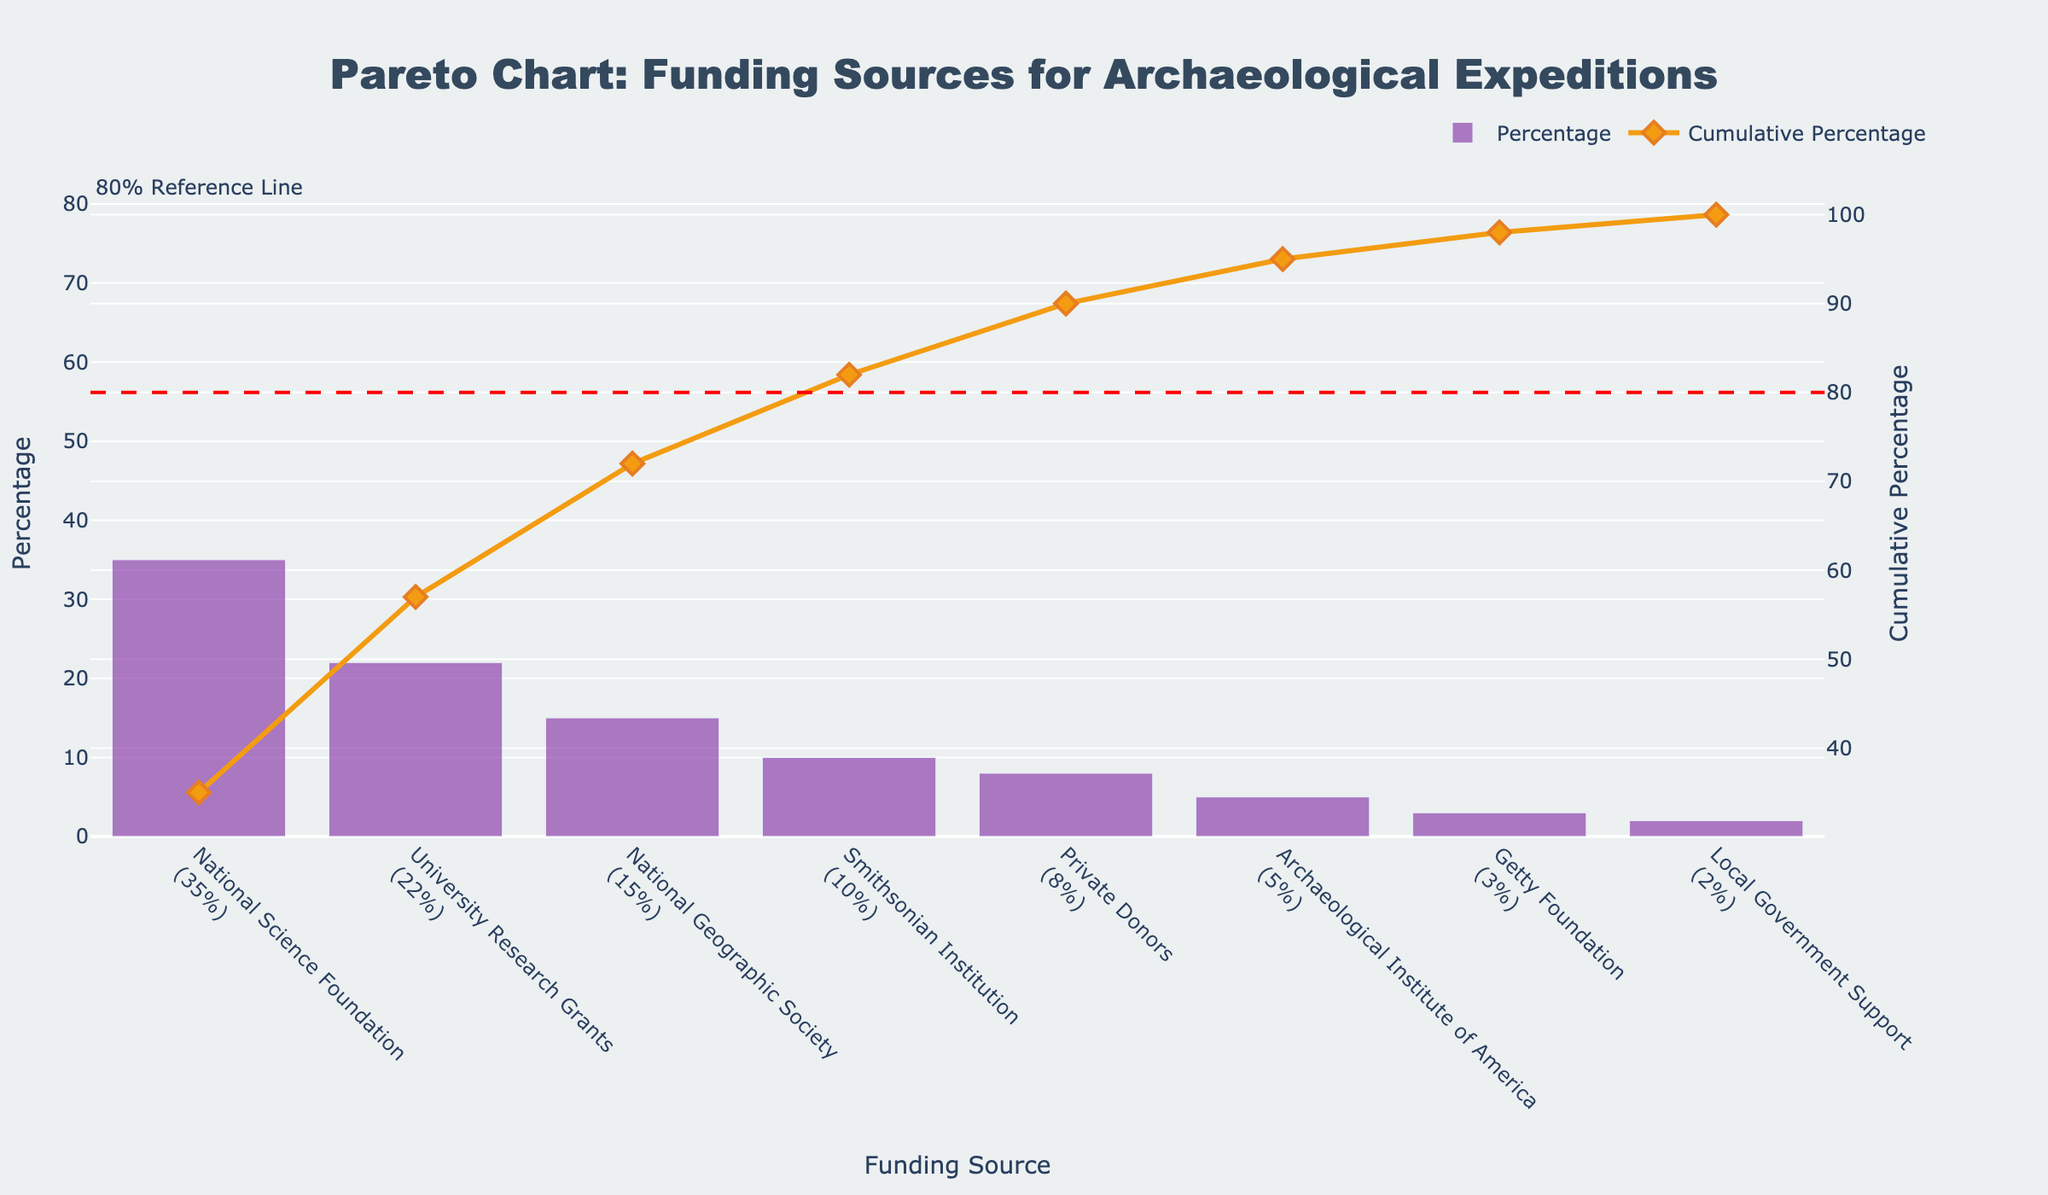What's the main title of this figure? The main title of the figure is displayed at the top, in bold and large font. It describes what the figure is about.
Answer: Pareto Chart: Funding Sources for Archaeological Expeditions Which funding source contributes the highest percentage? The funding sources are displayed along the x-axis, and their corresponding percentages are shown as bars. The tallest bar indicates the highest percentage.
Answer: National Science Foundation How does the cumulative percentage change from the first to the second funding source? The cumulative percentage is shown by the line graph. Observe the values at the first and second x-axis points and subtract.
Answer: It increases by 35% What is the total percentage contribution of the top three funding sources? Sum the percentages of the top three sources (35 + 22 + 15) to find the total.
Answer: 72% Which funding sources combined make up about 80% of the total funding? Look at the cumulative percentage line and find where it reaches around 80%. List down the corresponding funding sources up to that point.
Answer: National Science Foundation, University Research Grants, National Geographic Society, and Smithsonian Institution How many funding sources contribute less than 10% each? Look at the y-axis values and count the number of bars that are below the 10% mark.
Answer: Four (Private Donors, Archaeological Institute of America, Getty Foundation, Local Government Support) Which funding source is represented by the orange line symbol near 80%? The orange line represents the cumulative percentage. Check where this line is around 80% and find the corresponding funding source on the x-axis.
Answer: Smithsonian Institution Compare the contributions of National Geographic Society and Private Donors. Identify the bars for these two sources and compare their heights to determine which is larger and by how much.
Answer: National Geographic Society contributes 15%, which is 7% more than Private Donors at 8% What's the color of the bars representing the percentage contributions? Observe the color used to fill the bars in the chart.
Answer: Purple Identify the funding source with the smallest percentage contribution. Find the shortest bar on the chart, which represents the smallest percentage.
Answer: Local Government Support 